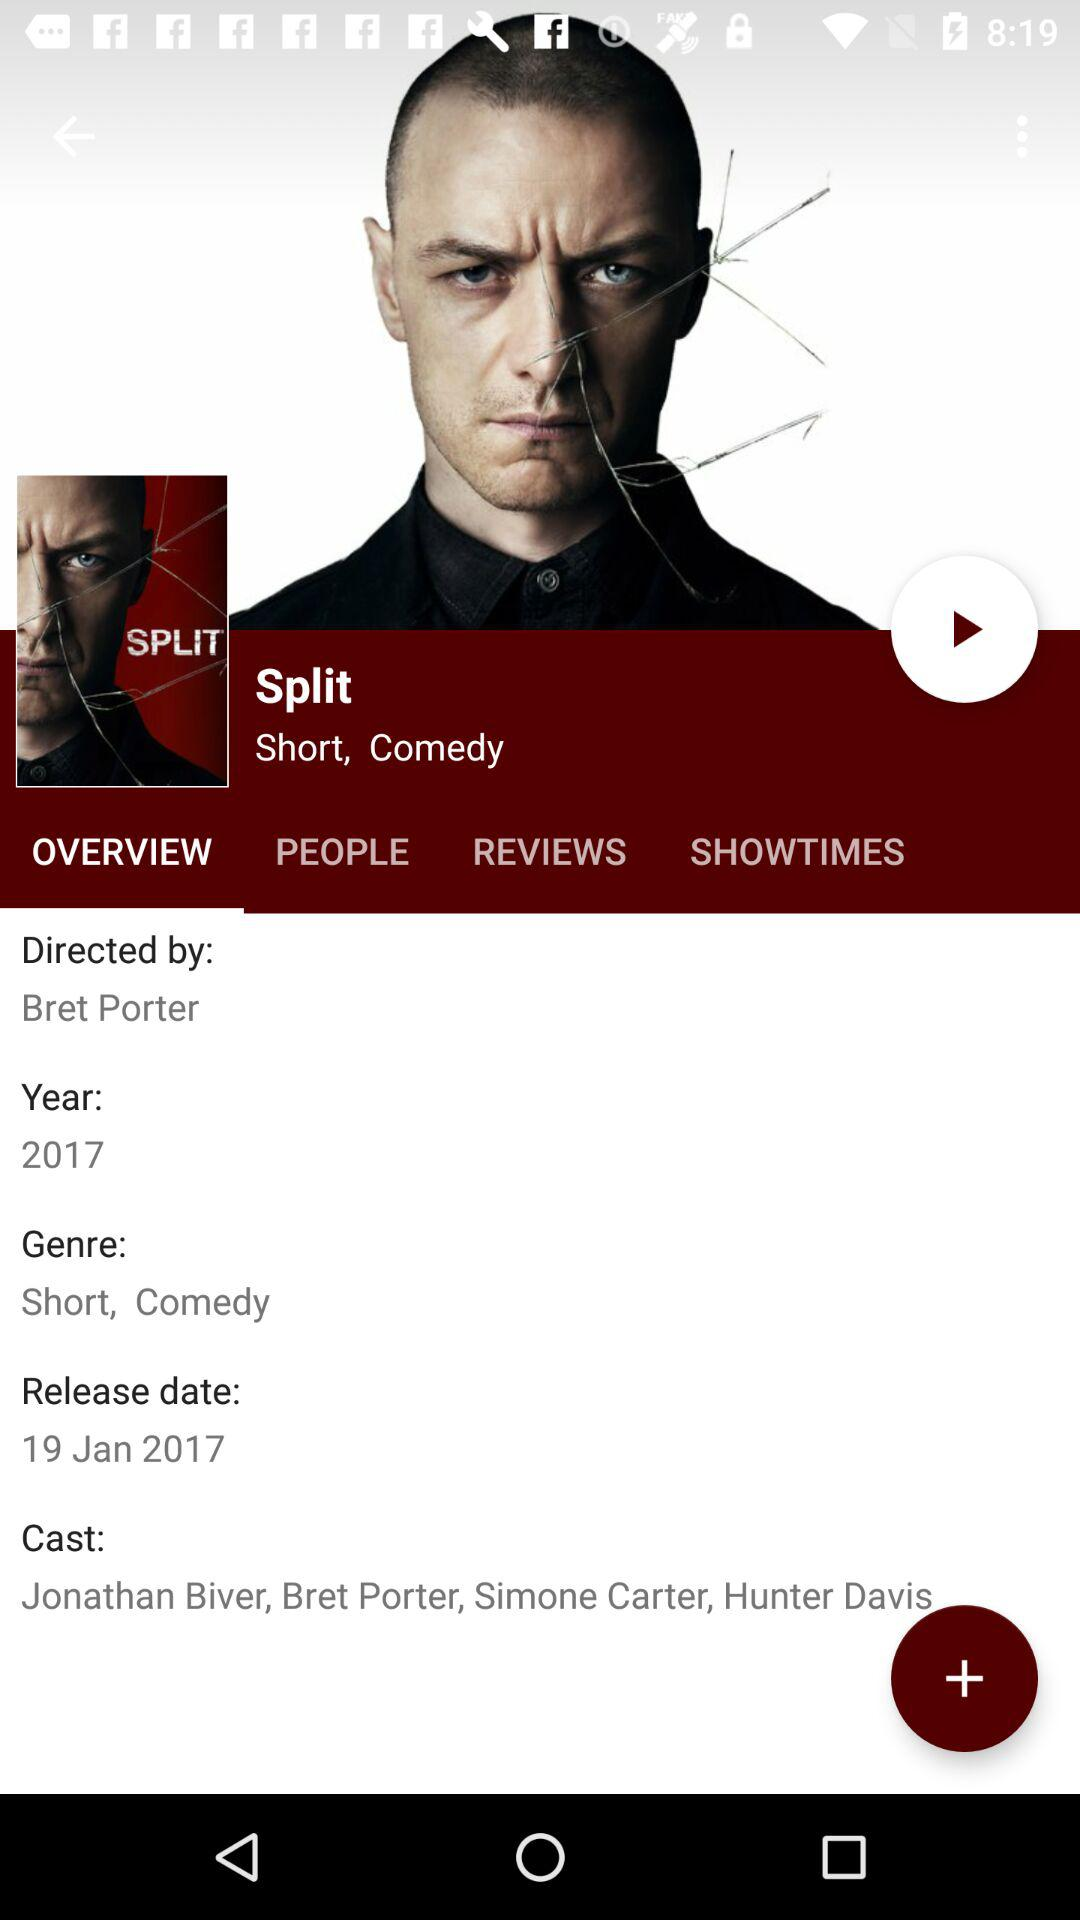What is the selected tab? The selected tab is "OVERVIEW". 